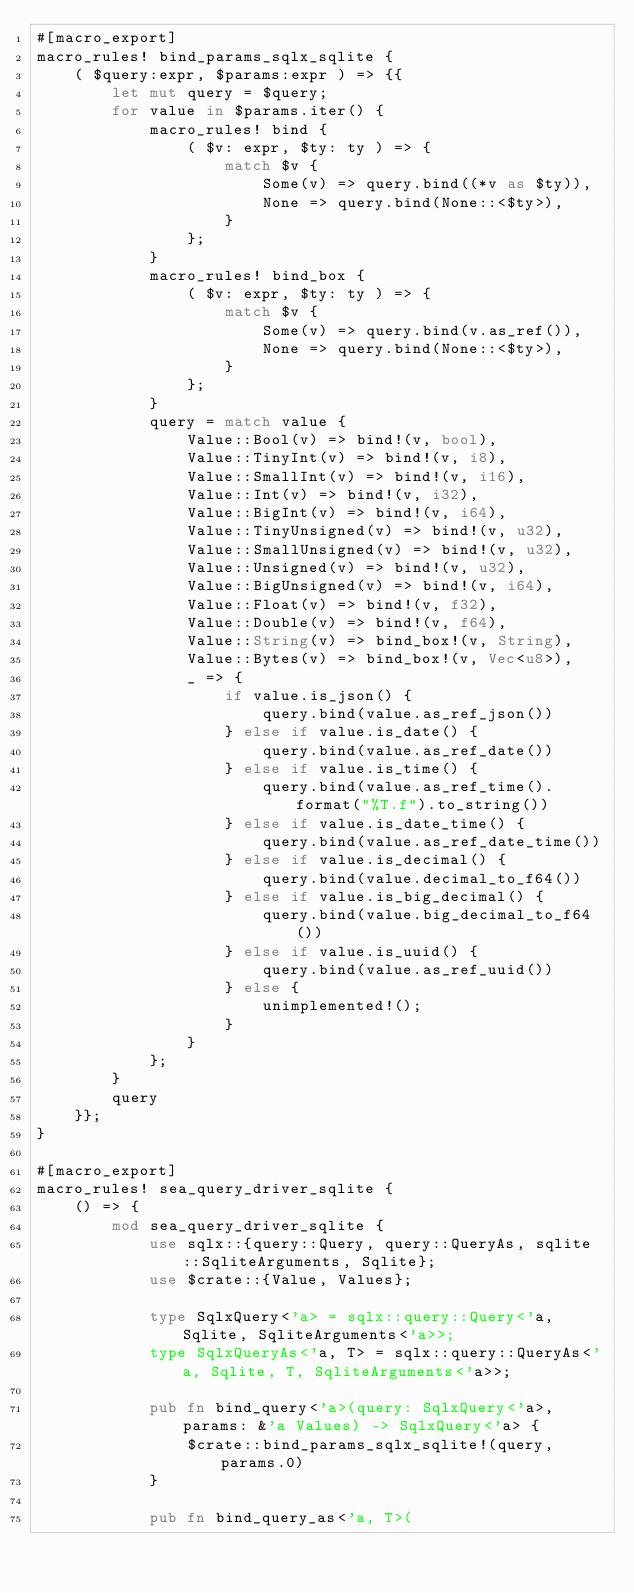<code> <loc_0><loc_0><loc_500><loc_500><_Rust_>#[macro_export]
macro_rules! bind_params_sqlx_sqlite {
    ( $query:expr, $params:expr ) => {{
        let mut query = $query;
        for value in $params.iter() {
            macro_rules! bind {
                ( $v: expr, $ty: ty ) => {
                    match $v {
                        Some(v) => query.bind((*v as $ty)),
                        None => query.bind(None::<$ty>),
                    }
                };
            }
            macro_rules! bind_box {
                ( $v: expr, $ty: ty ) => {
                    match $v {
                        Some(v) => query.bind(v.as_ref()),
                        None => query.bind(None::<$ty>),
                    }
                };
            }
            query = match value {
                Value::Bool(v) => bind!(v, bool),
                Value::TinyInt(v) => bind!(v, i8),
                Value::SmallInt(v) => bind!(v, i16),
                Value::Int(v) => bind!(v, i32),
                Value::BigInt(v) => bind!(v, i64),
                Value::TinyUnsigned(v) => bind!(v, u32),
                Value::SmallUnsigned(v) => bind!(v, u32),
                Value::Unsigned(v) => bind!(v, u32),
                Value::BigUnsigned(v) => bind!(v, i64),
                Value::Float(v) => bind!(v, f32),
                Value::Double(v) => bind!(v, f64),
                Value::String(v) => bind_box!(v, String),
                Value::Bytes(v) => bind_box!(v, Vec<u8>),
                _ => {
                    if value.is_json() {
                        query.bind(value.as_ref_json())
                    } else if value.is_date() {
                        query.bind(value.as_ref_date())
                    } else if value.is_time() {
                        query.bind(value.as_ref_time().format("%T.f").to_string())
                    } else if value.is_date_time() {
                        query.bind(value.as_ref_date_time())
                    } else if value.is_decimal() {
                        query.bind(value.decimal_to_f64())
                    } else if value.is_big_decimal() {
                        query.bind(value.big_decimal_to_f64())
                    } else if value.is_uuid() {
                        query.bind(value.as_ref_uuid())
                    } else {
                        unimplemented!();
                    }
                }
            };
        }
        query
    }};
}

#[macro_export]
macro_rules! sea_query_driver_sqlite {
    () => {
        mod sea_query_driver_sqlite {
            use sqlx::{query::Query, query::QueryAs, sqlite::SqliteArguments, Sqlite};
            use $crate::{Value, Values};

            type SqlxQuery<'a> = sqlx::query::Query<'a, Sqlite, SqliteArguments<'a>>;
            type SqlxQueryAs<'a, T> = sqlx::query::QueryAs<'a, Sqlite, T, SqliteArguments<'a>>;

            pub fn bind_query<'a>(query: SqlxQuery<'a>, params: &'a Values) -> SqlxQuery<'a> {
                $crate::bind_params_sqlx_sqlite!(query, params.0)
            }

            pub fn bind_query_as<'a, T>(</code> 